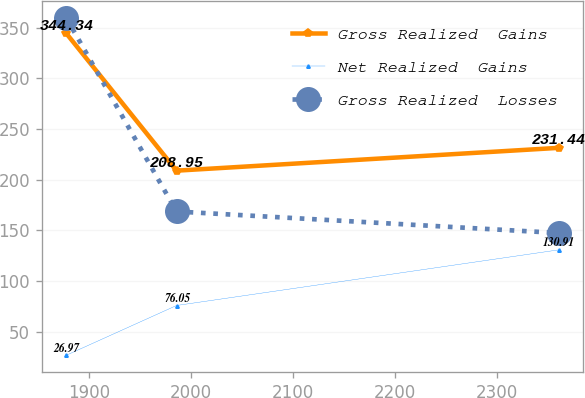Convert chart. <chart><loc_0><loc_0><loc_500><loc_500><line_chart><ecel><fcel>Gross Realized  Gains<fcel>Net Realized  Gains<fcel>Gross Realized  Losses<nl><fcel>1877.83<fcel>344.34<fcel>26.97<fcel>359.61<nl><fcel>1985.83<fcel>208.95<fcel>76.05<fcel>168.71<nl><fcel>2360.16<fcel>231.44<fcel>130.91<fcel>147.5<nl></chart> 